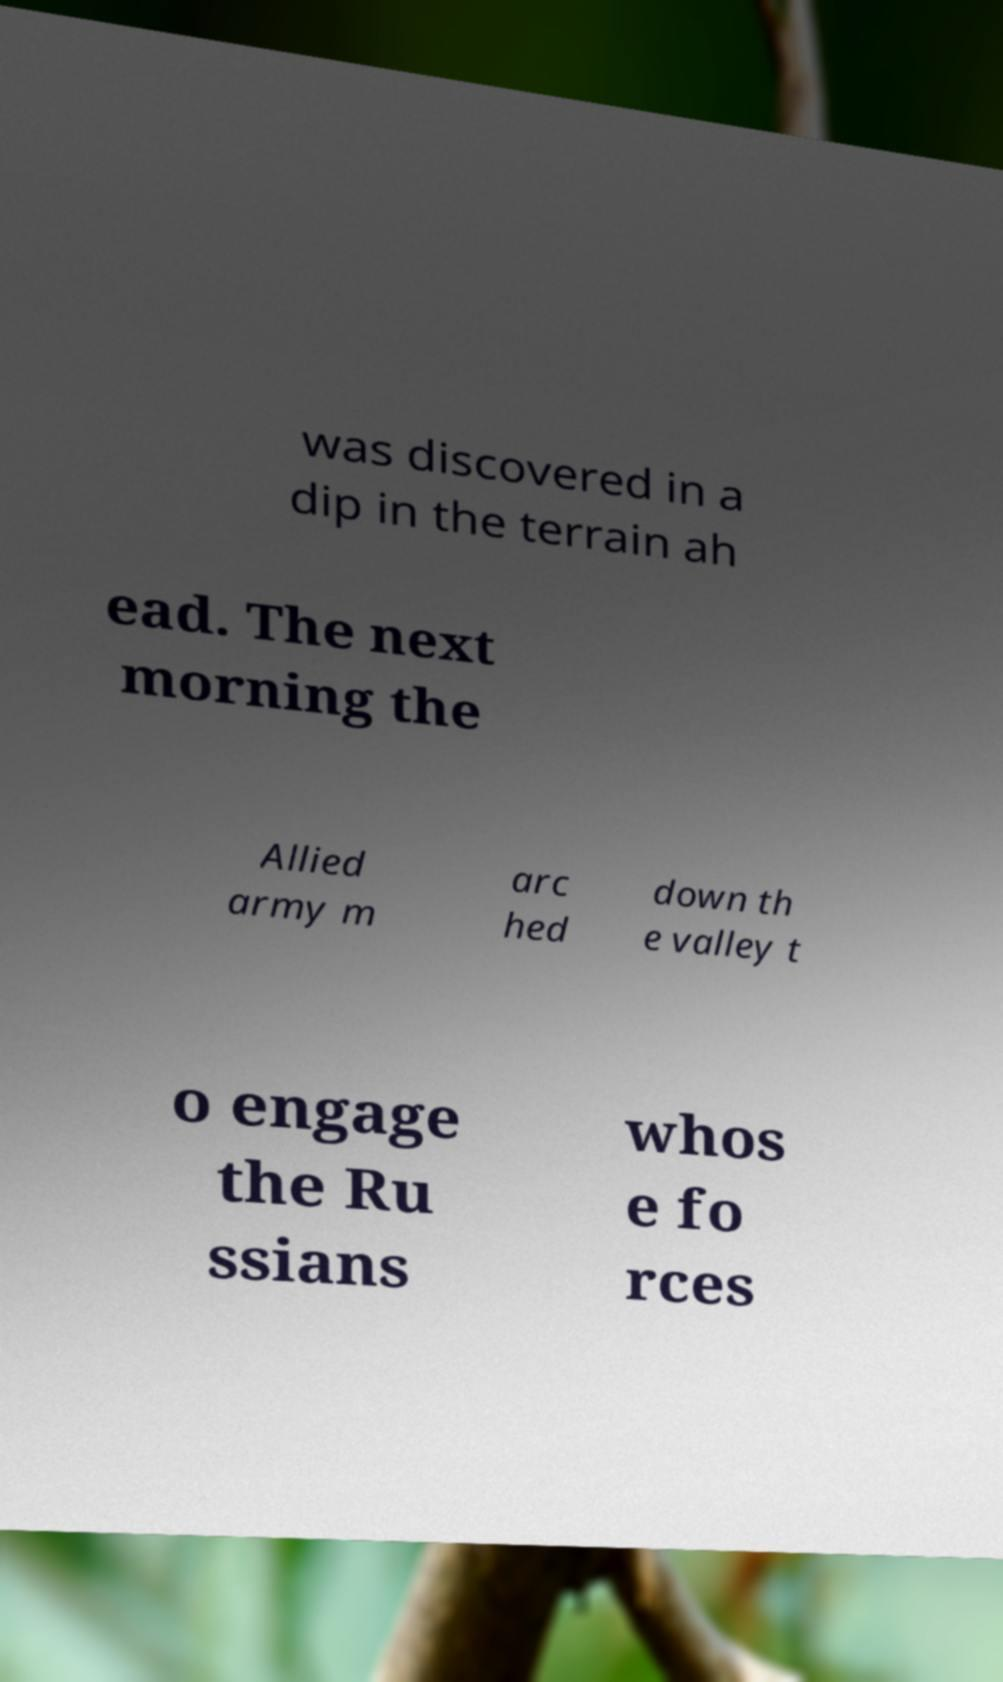Could you extract and type out the text from this image? was discovered in a dip in the terrain ah ead. The next morning the Allied army m arc hed down th e valley t o engage the Ru ssians whos e fo rces 